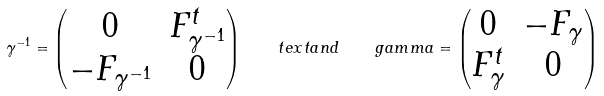<formula> <loc_0><loc_0><loc_500><loc_500>\gamma ^ { - 1 } = \begin{pmatrix} 0 & F ^ { t } _ { \gamma ^ { - 1 } } \\ - F _ { \gamma ^ { - 1 } } & 0 \end{pmatrix} \quad t e x t { a n d } \quad g a m m a = \begin{pmatrix} 0 & - F _ { \gamma } \\ F ^ { t } _ { \gamma } & 0 \end{pmatrix}</formula> 